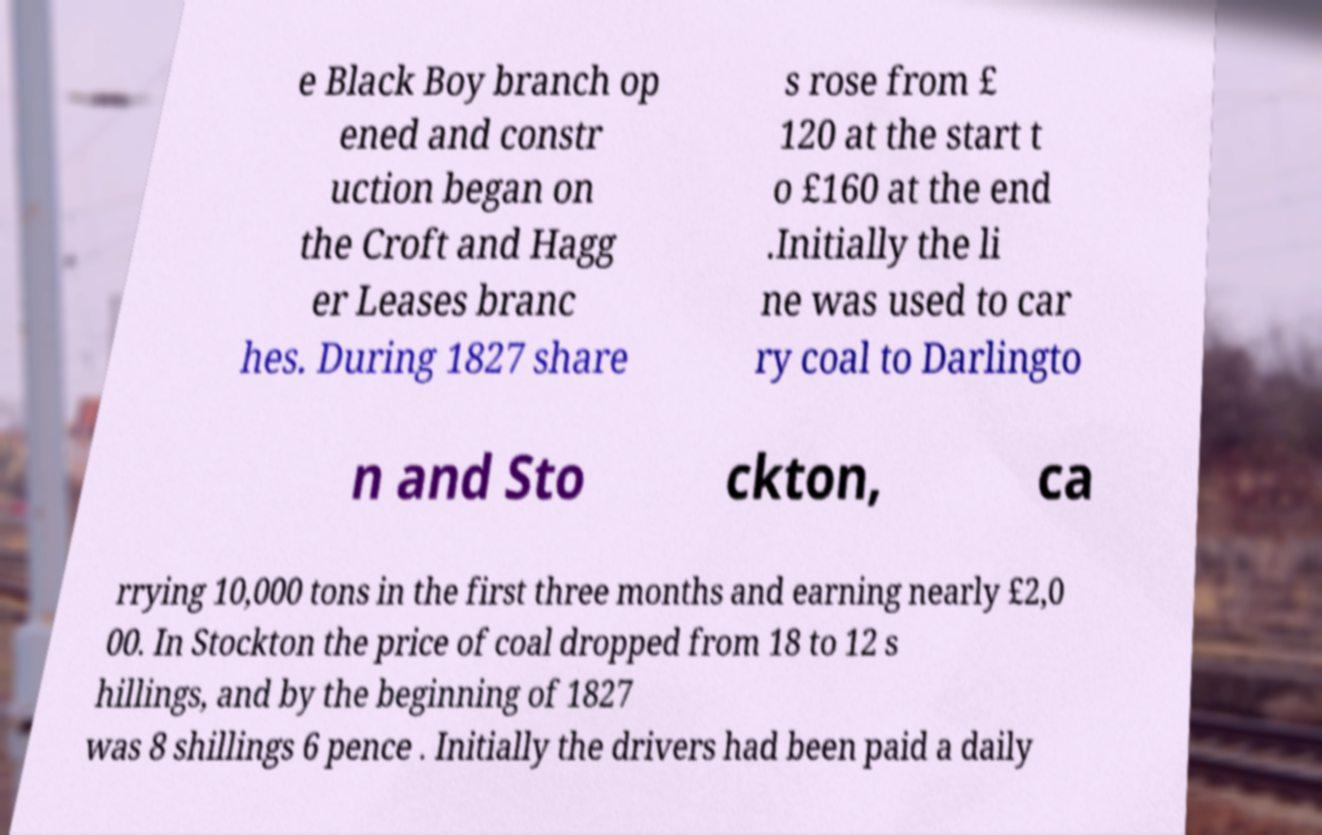Please identify and transcribe the text found in this image. e Black Boy branch op ened and constr uction began on the Croft and Hagg er Leases branc hes. During 1827 share s rose from £ 120 at the start t o £160 at the end .Initially the li ne was used to car ry coal to Darlingto n and Sto ckton, ca rrying 10,000 tons in the first three months and earning nearly £2,0 00. In Stockton the price of coal dropped from 18 to 12 s hillings, and by the beginning of 1827 was 8 shillings 6 pence . Initially the drivers had been paid a daily 